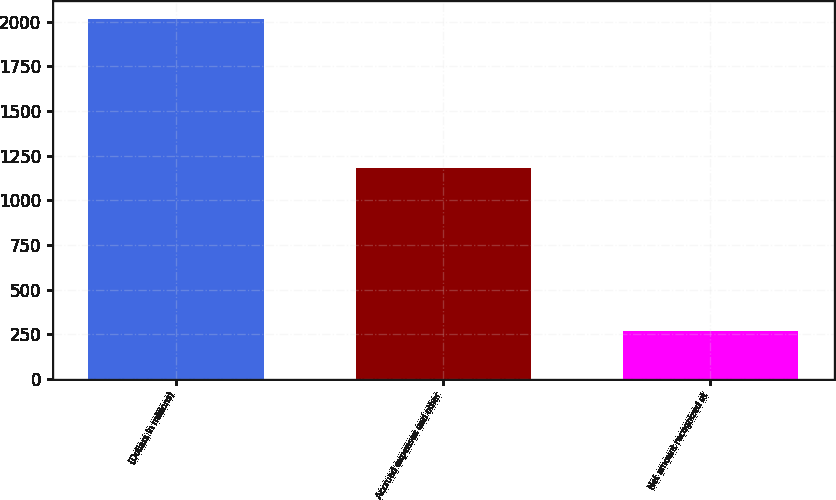Convert chart. <chart><loc_0><loc_0><loc_500><loc_500><bar_chart><fcel>(Dollars in millions)<fcel>Accrued expenses and other<fcel>Net amount recognized at<nl><fcel>2012<fcel>1179<fcel>271<nl></chart> 